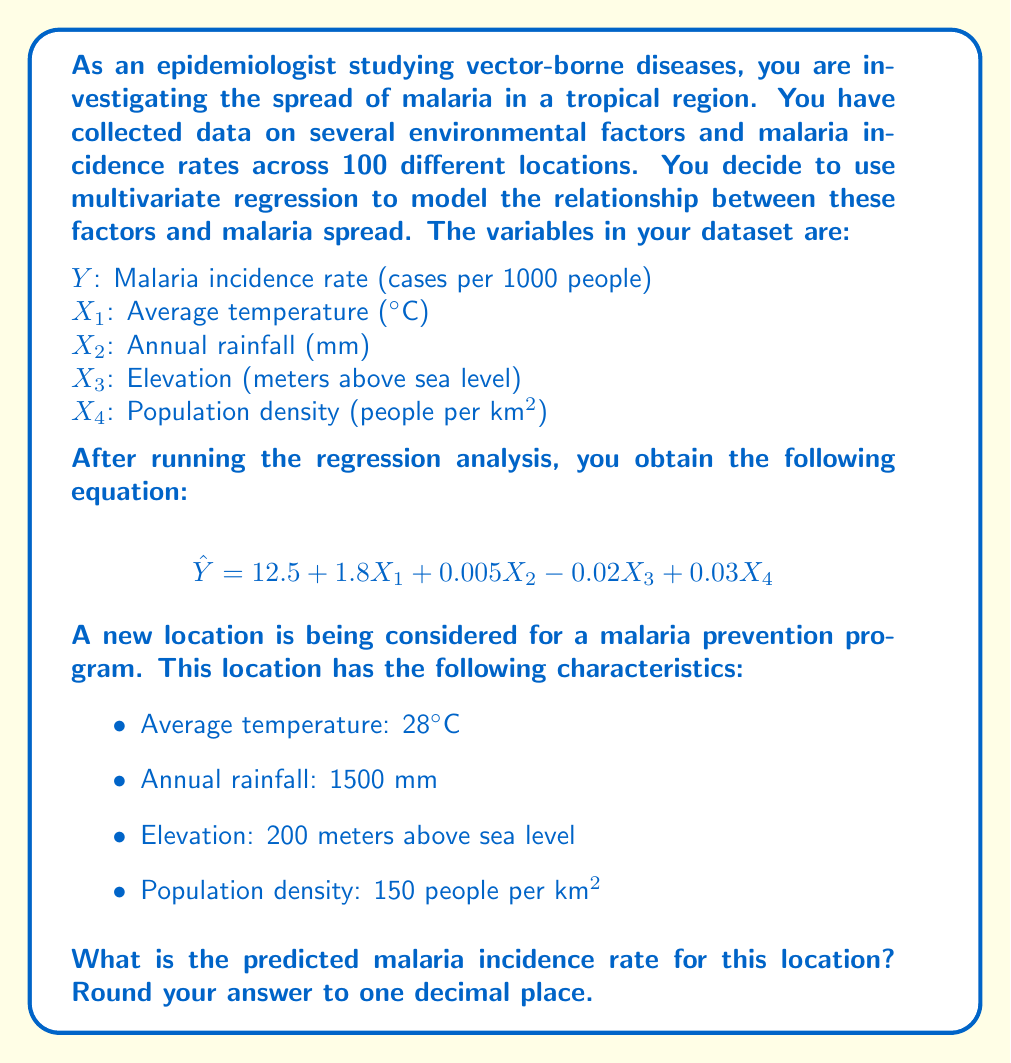Could you help me with this problem? To solve this problem, we need to use the multivariate regression equation provided and substitute the values for the new location. Let's break it down step by step:

1. The regression equation is:
   $$\hat{Y} = 12.5 + 1.8X_1 + 0.005X_2 - 0.02X_3 + 0.03X_4$$

2. We have the following values for the new location:
   $X_1 = 28$ (Average temperature)
   $X_2 = 1500$ (Annual rainfall)
   $X_3 = 200$ (Elevation)
   $X_4 = 150$ (Population density)

3. Let's substitute these values into the equation:

   $$\begin{align}
   \hat{Y} &= 12.5 + 1.8(28) + 0.005(1500) - 0.02(200) + 0.03(150) \\
   &= 12.5 + 50.4 + 7.5 - 4 + 4.5
   \end{align}$$

4. Now, let's calculate the result:

   $$\begin{align}
   \hat{Y} &= 12.5 + 50.4 + 7.5 - 4 + 4.5 \\
   &= 70.9
   \end{align}$$

5. Rounding to one decimal place, we get 70.9.

Therefore, the predicted malaria incidence rate for this location is 70.9 cases per 1000 people.
Answer: 70.9 cases per 1000 people 